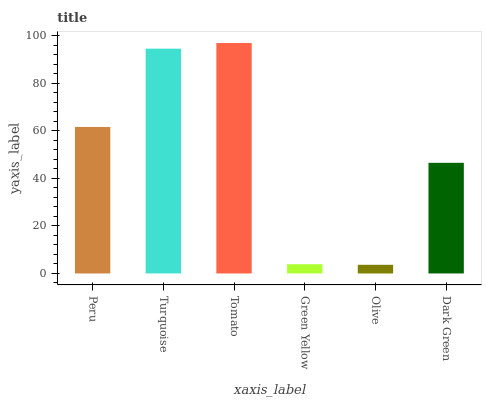Is Olive the minimum?
Answer yes or no. Yes. Is Tomato the maximum?
Answer yes or no. Yes. Is Turquoise the minimum?
Answer yes or no. No. Is Turquoise the maximum?
Answer yes or no. No. Is Turquoise greater than Peru?
Answer yes or no. Yes. Is Peru less than Turquoise?
Answer yes or no. Yes. Is Peru greater than Turquoise?
Answer yes or no. No. Is Turquoise less than Peru?
Answer yes or no. No. Is Peru the high median?
Answer yes or no. Yes. Is Dark Green the low median?
Answer yes or no. Yes. Is Green Yellow the high median?
Answer yes or no. No. Is Peru the low median?
Answer yes or no. No. 